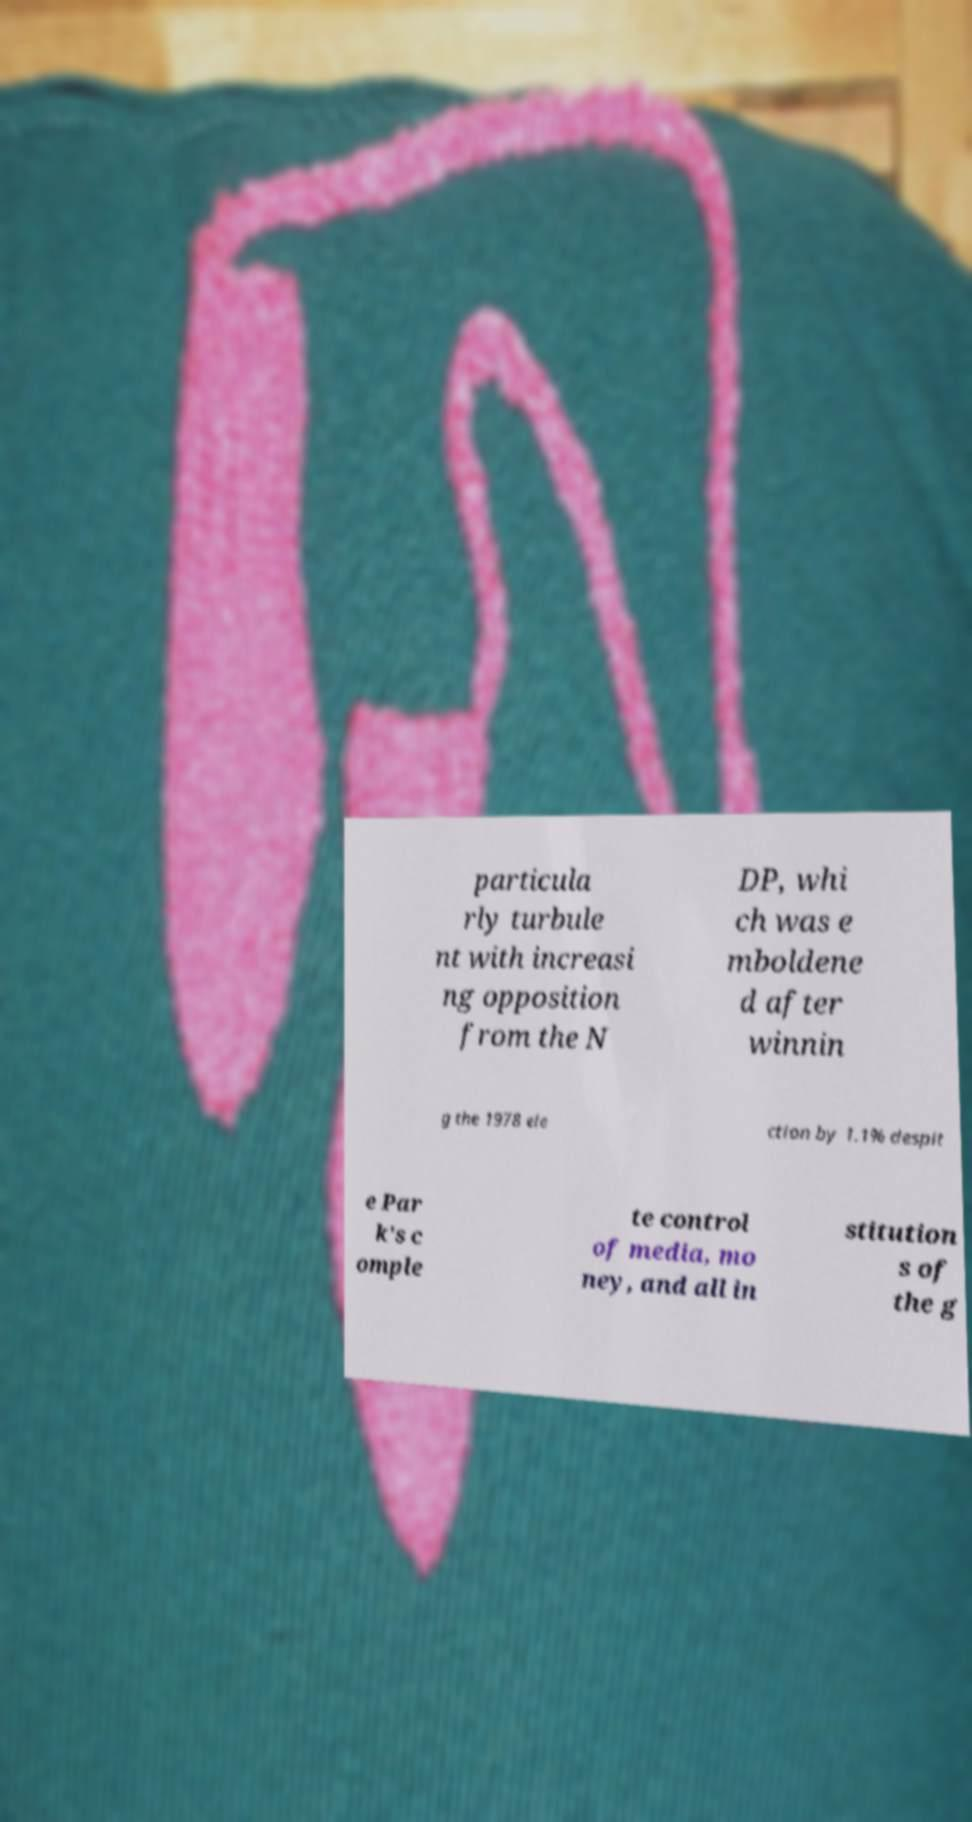Can you read and provide the text displayed in the image?This photo seems to have some interesting text. Can you extract and type it out for me? particula rly turbule nt with increasi ng opposition from the N DP, whi ch was e mboldene d after winnin g the 1978 ele ction by 1.1% despit e Par k's c omple te control of media, mo ney, and all in stitution s of the g 